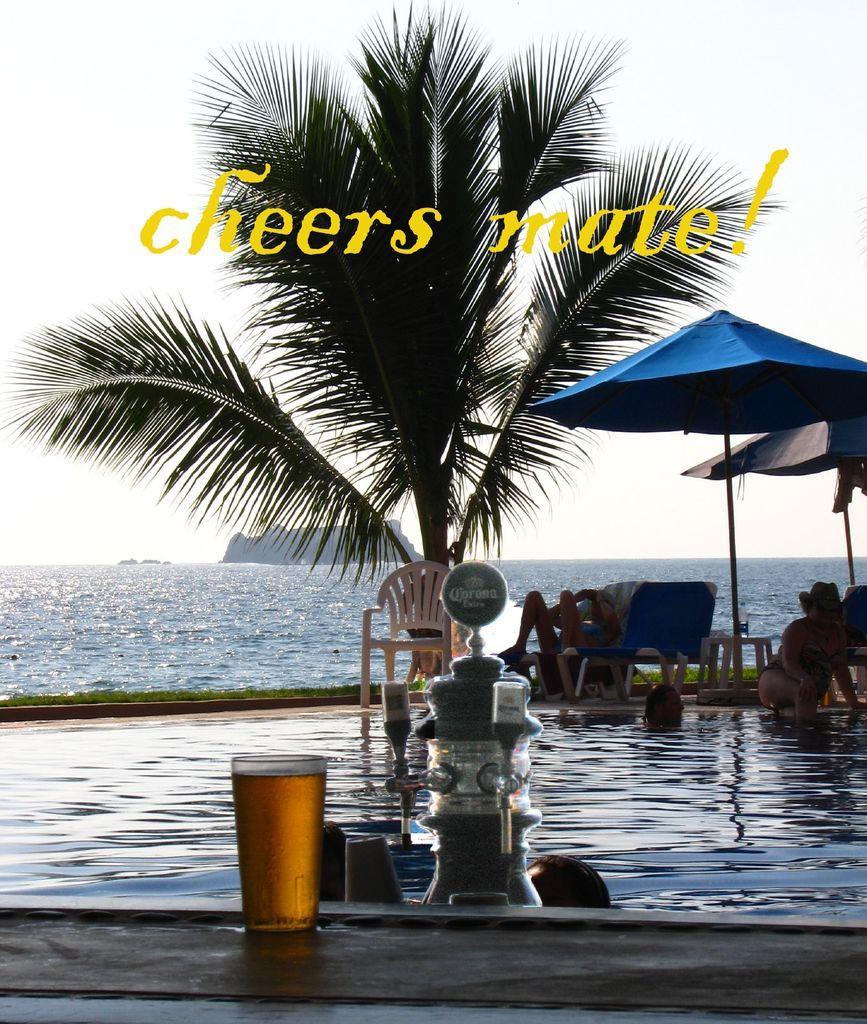Can you describe this image briefly? In this image we can see one sea, along with mountains. On the surface one big tree, some grass is there. Some chairs are there one girl sitting on a chair. One table is there along with a tent. The water bottle is on the table. With swimming pool there are three persons. One woman is sitting near the pool. Here on bar jug is there and on the surface Glass of wine is there. 